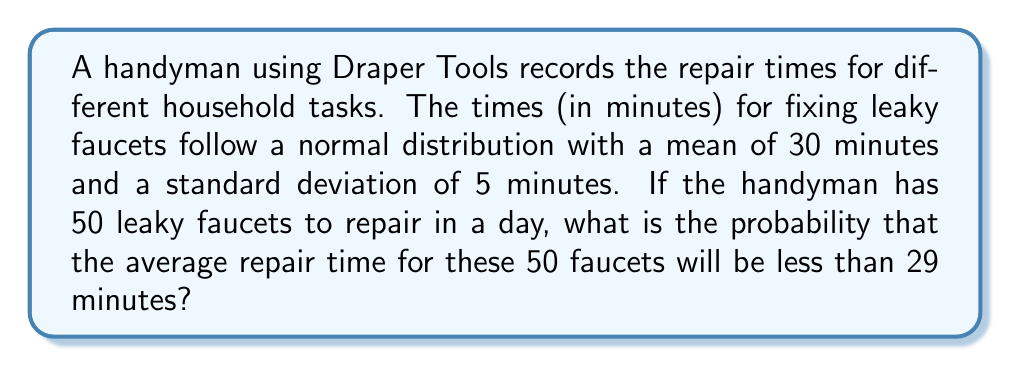Could you help me with this problem? Let's approach this step-by-step:

1) First, we need to recognize that we're dealing with the sampling distribution of the mean. The Central Limit Theorem tells us that for a large sample size (n ≥ 30), the sampling distribution of the mean is approximately normal.

2) We're given:
   - Population mean (μ) = 30 minutes
   - Population standard deviation (σ) = 5 minutes
   - Sample size (n) = 50

3) The mean of the sampling distribution is equal to the population mean:
   μ_X̄ = μ = 30

4) The standard deviation of the sampling distribution (standard error) is:
   σ_X̄ = σ / √n = 5 / √50 = 5 / 7.071 ≈ 0.7071

5) We want to find P(X̄ < 29), so we need to calculate the z-score:
   z = (x - μ_X̄) / σ_X̄
   z = (29 - 30) / 0.7071 ≈ -1.4142

6) Now we need to find the probability of z < -1.4142 using the standard normal distribution table or a calculator.

7) Using a standard normal table or calculator, we find:
   P(Z < -1.4142) ≈ 0.0786

Thus, the probability that the average repair time for 50 faucets will be less than 29 minutes is approximately 0.0786 or 7.86%.
Answer: 0.0786 